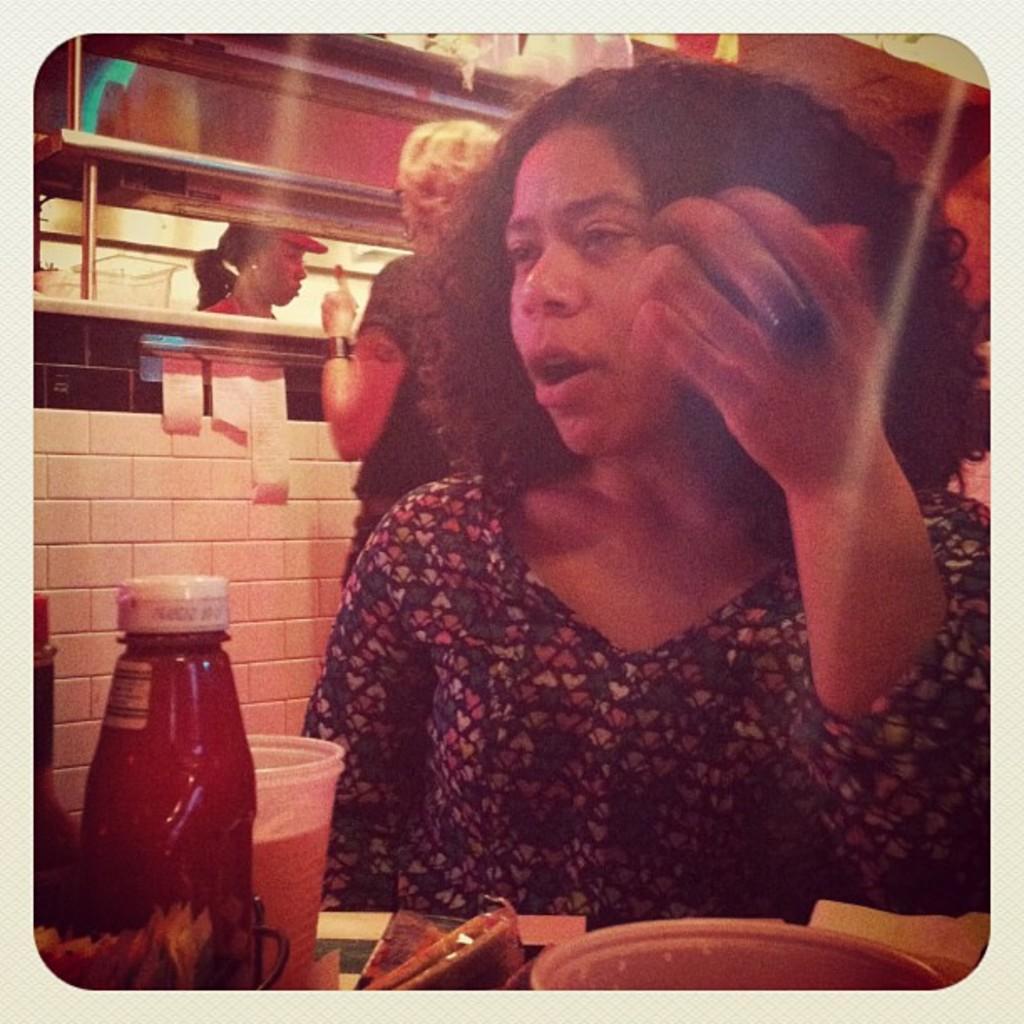Could you give a brief overview of what you see in this image? In this picture we can see a woman,here we can see a bottle,glass,bowl and in the background we can see a wall,people. 